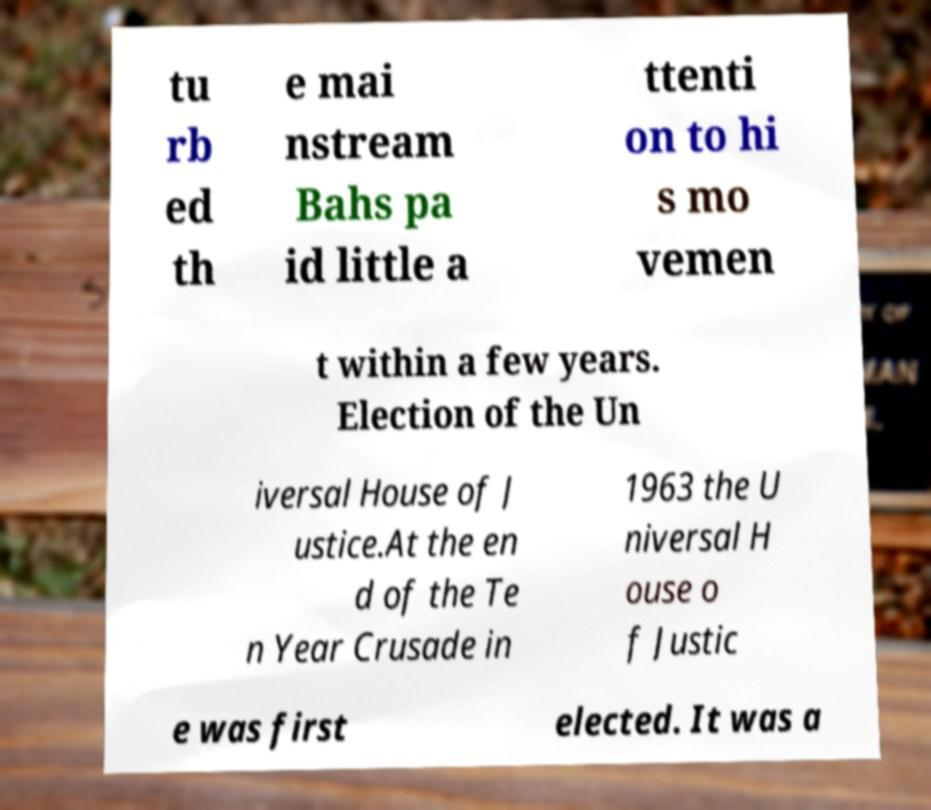For documentation purposes, I need the text within this image transcribed. Could you provide that? tu rb ed th e mai nstream Bahs pa id little a ttenti on to hi s mo vemen t within a few years. Election of the Un iversal House of J ustice.At the en d of the Te n Year Crusade in 1963 the U niversal H ouse o f Justic e was first elected. It was a 